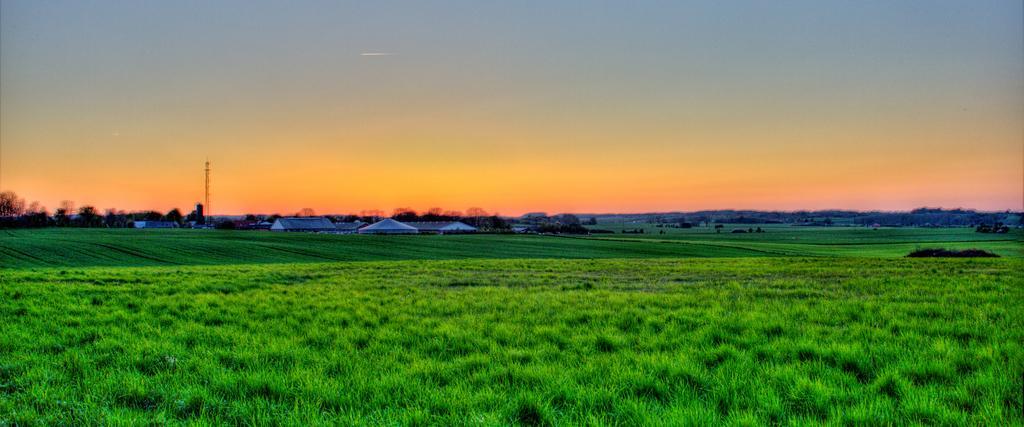How would you summarize this image in a sentence or two? The ground is greenery and there are few buildings and trees in the background. 